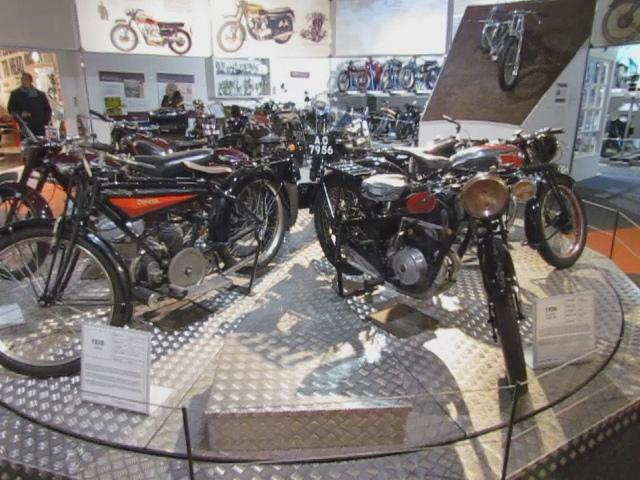What type room is this? showroom 